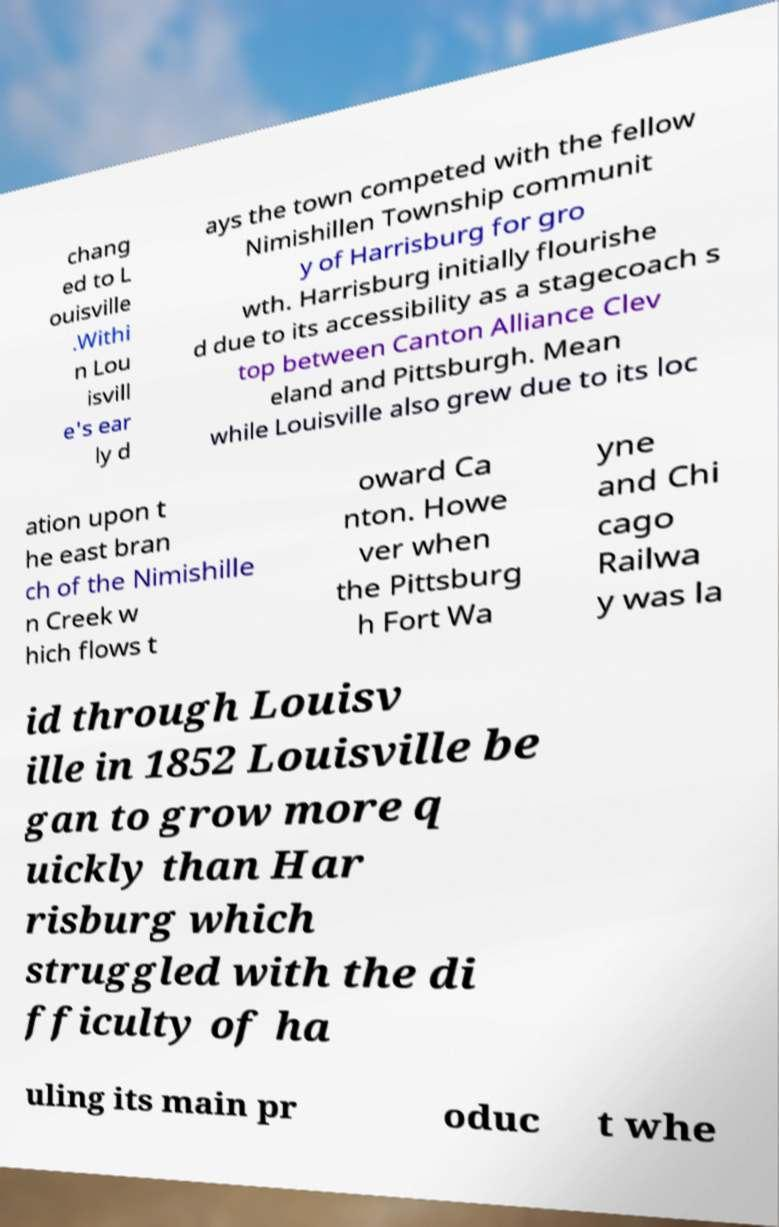Can you read and provide the text displayed in the image?This photo seems to have some interesting text. Can you extract and type it out for me? chang ed to L ouisville .Withi n Lou isvill e's ear ly d ays the town competed with the fellow Nimishillen Township communit y of Harrisburg for gro wth. Harrisburg initially flourishe d due to its accessibility as a stagecoach s top between Canton Alliance Clev eland and Pittsburgh. Mean while Louisville also grew due to its loc ation upon t he east bran ch of the Nimishille n Creek w hich flows t oward Ca nton. Howe ver when the Pittsburg h Fort Wa yne and Chi cago Railwa y was la id through Louisv ille in 1852 Louisville be gan to grow more q uickly than Har risburg which struggled with the di fficulty of ha uling its main pr oduc t whe 